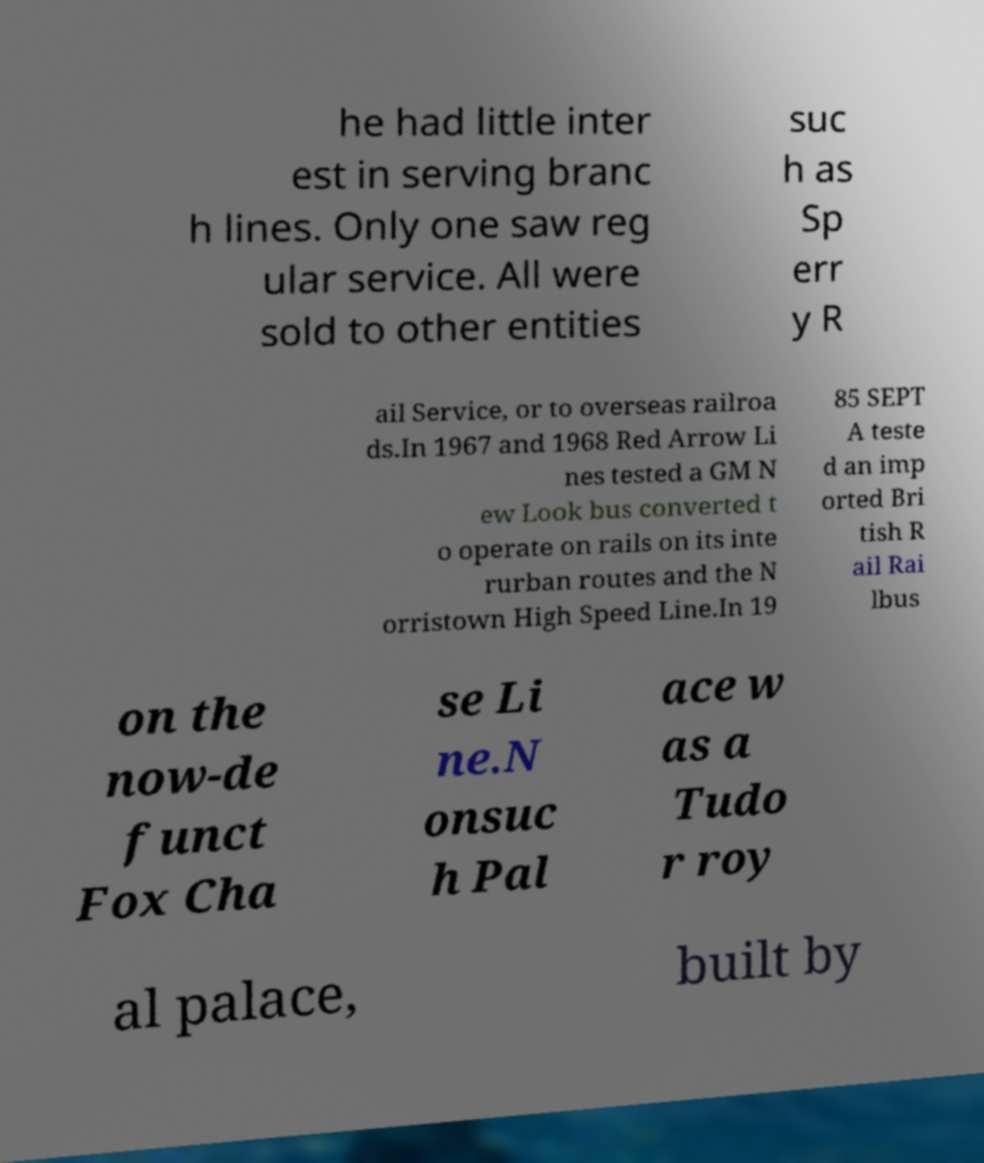Please identify and transcribe the text found in this image. he had little inter est in serving branc h lines. Only one saw reg ular service. All were sold to other entities suc h as Sp err y R ail Service, or to overseas railroa ds.In 1967 and 1968 Red Arrow Li nes tested a GM N ew Look bus converted t o operate on rails on its inte rurban routes and the N orristown High Speed Line.In 19 85 SEPT A teste d an imp orted Bri tish R ail Rai lbus on the now-de funct Fox Cha se Li ne.N onsuc h Pal ace w as a Tudo r roy al palace, built by 